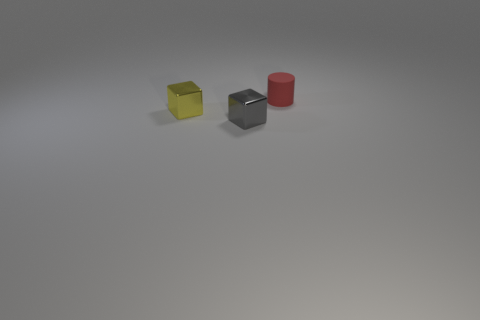Add 1 tiny yellow matte blocks. How many objects exist? 4 Subtract all blocks. How many objects are left? 1 Add 1 red cylinders. How many red cylinders exist? 2 Subtract 0 gray cylinders. How many objects are left? 3 Subtract all small things. Subtract all small blue cylinders. How many objects are left? 0 Add 2 small gray objects. How many small gray objects are left? 3 